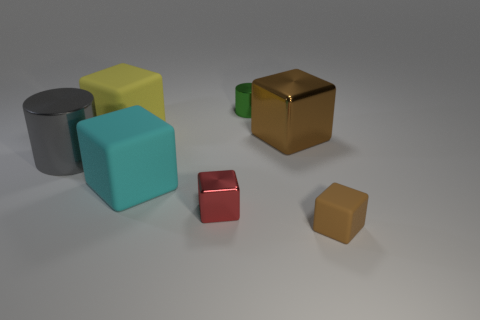There is a cylinder in front of the tiny green metallic thing; what is its material? metal 